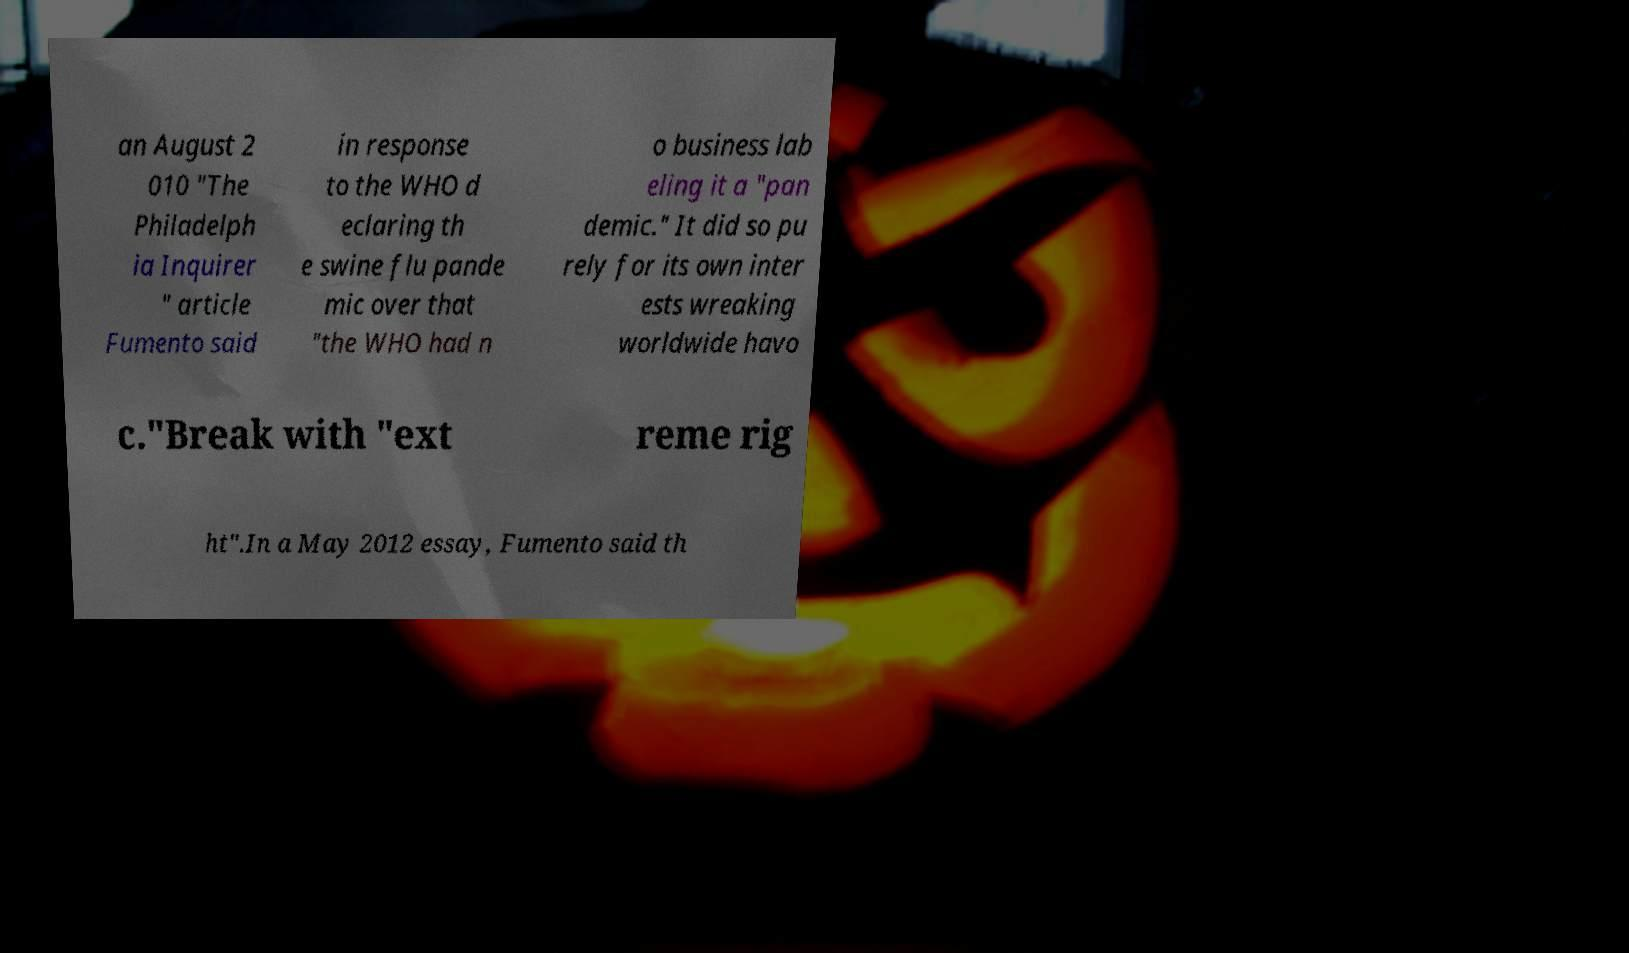Could you extract and type out the text from this image? an August 2 010 "The Philadelph ia Inquirer " article Fumento said in response to the WHO d eclaring th e swine flu pande mic over that "the WHO had n o business lab eling it a "pan demic." It did so pu rely for its own inter ests wreaking worldwide havo c."Break with "ext reme rig ht".In a May 2012 essay, Fumento said th 